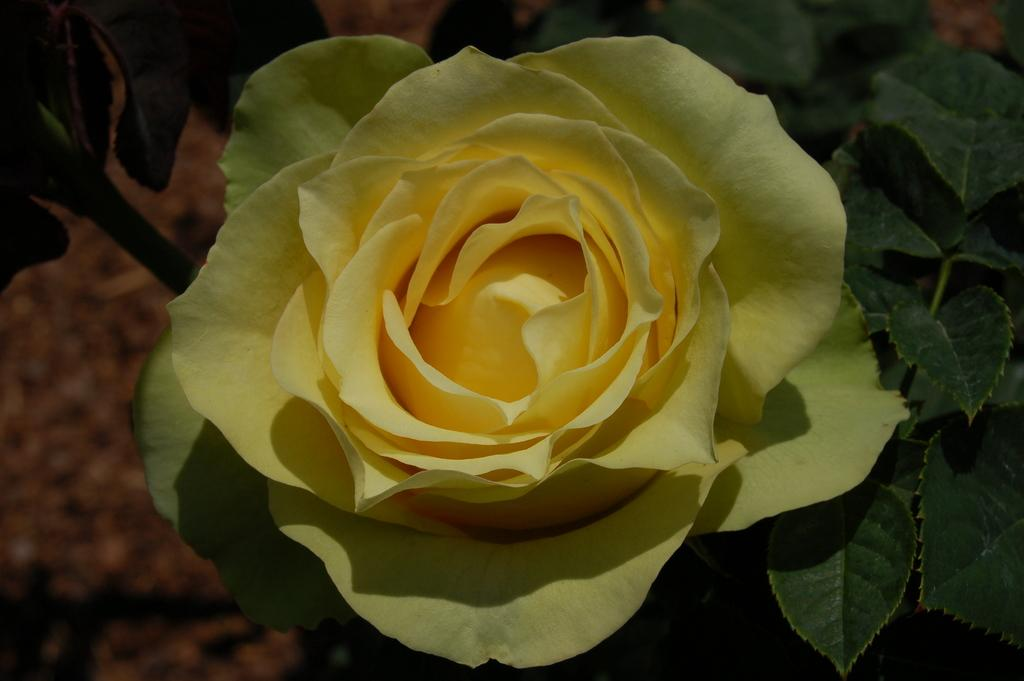What type of plant is in the image? There is a rose plant in the image. What color is the rose on the plant? The rose plant has a yellow rose. Where is the rose plant located? The rose plant is on the ground. Can you describe the background of the image? The background of the image is blurred. What type of wire is used to hold the cent in the image? There is no wire or cent present in the image; it features a rose plant with a yellow rose on the ground. Is there a rifle visible in the image? No, there is no rifle present in the image. 